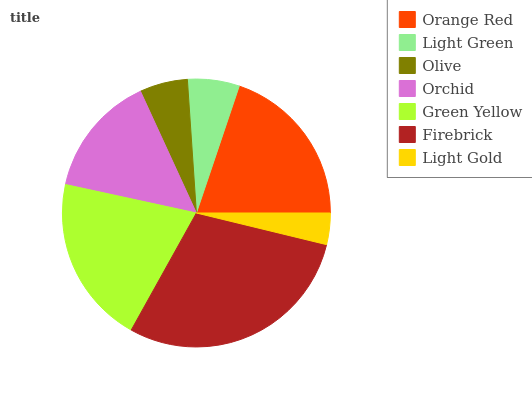Is Light Gold the minimum?
Answer yes or no. Yes. Is Firebrick the maximum?
Answer yes or no. Yes. Is Light Green the minimum?
Answer yes or no. No. Is Light Green the maximum?
Answer yes or no. No. Is Orange Red greater than Light Green?
Answer yes or no. Yes. Is Light Green less than Orange Red?
Answer yes or no. Yes. Is Light Green greater than Orange Red?
Answer yes or no. No. Is Orange Red less than Light Green?
Answer yes or no. No. Is Orchid the high median?
Answer yes or no. Yes. Is Orchid the low median?
Answer yes or no. Yes. Is Firebrick the high median?
Answer yes or no. No. Is Green Yellow the low median?
Answer yes or no. No. 